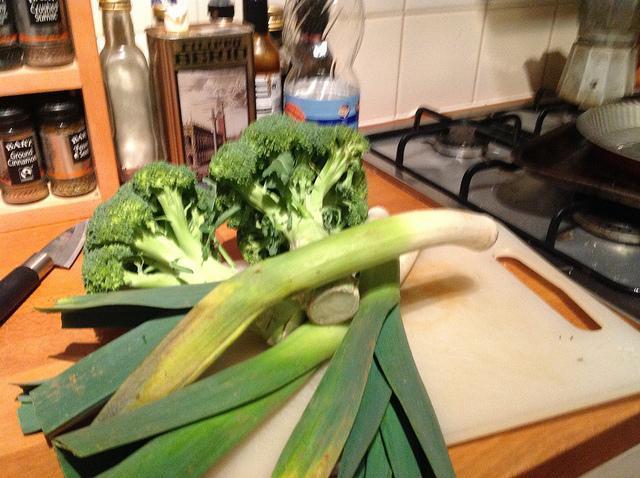How many broccolis are visible?
Give a very brief answer. 2. How many bottles are in the photo?
Give a very brief answer. 6. 